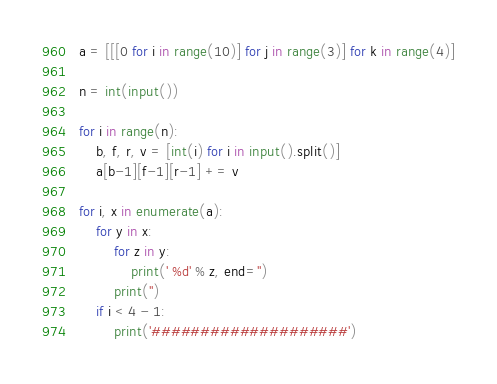<code> <loc_0><loc_0><loc_500><loc_500><_Python_>a = [[[0 for i in range(10)] for j in range(3)] for k in range(4)]

n = int(input())

for i in range(n):
    b, f, r, v = [int(i) for i in input().split()]
    a[b-1][f-1][r-1] += v

for i, x in enumerate(a):
    for y in x:
        for z in y:
            print(' %d' % z, end='')
        print('')
    if i < 4 - 1:
        print('####################')</code> 